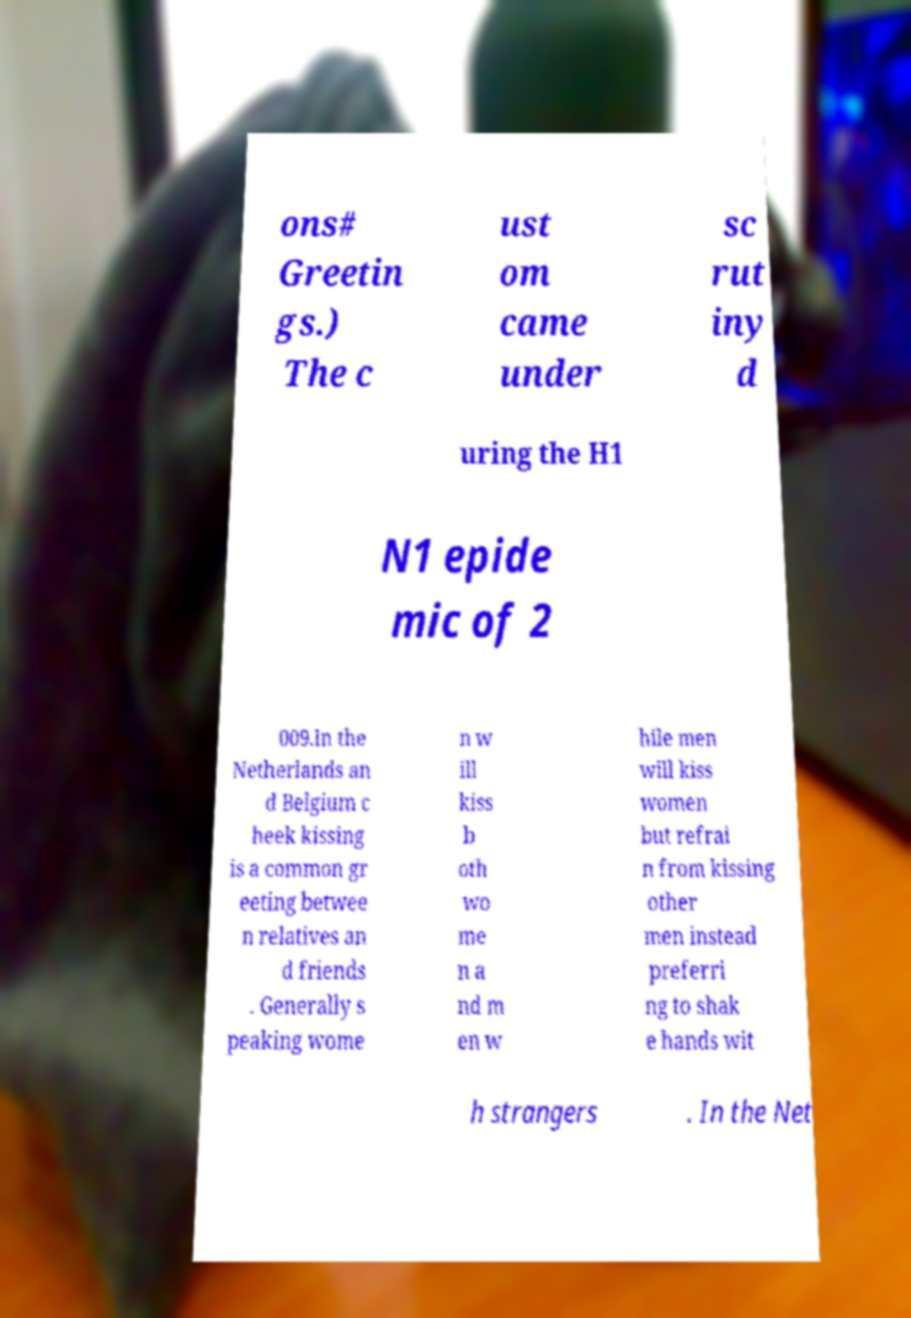Can you read and provide the text displayed in the image?This photo seems to have some interesting text. Can you extract and type it out for me? ons# Greetin gs.) The c ust om came under sc rut iny d uring the H1 N1 epide mic of 2 009.In the Netherlands an d Belgium c heek kissing is a common gr eeting betwee n relatives an d friends . Generally s peaking wome n w ill kiss b oth wo me n a nd m en w hile men will kiss women but refrai n from kissing other men instead preferri ng to shak e hands wit h strangers . In the Net 